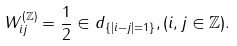<formula> <loc_0><loc_0><loc_500><loc_500>W ^ { ( \mathbb { Z } ) } _ { i j } = \frac { 1 } { 2 } \in d _ { \{ | i - j | = 1 \} } , ( i , j \in \mathbb { Z } ) .</formula> 